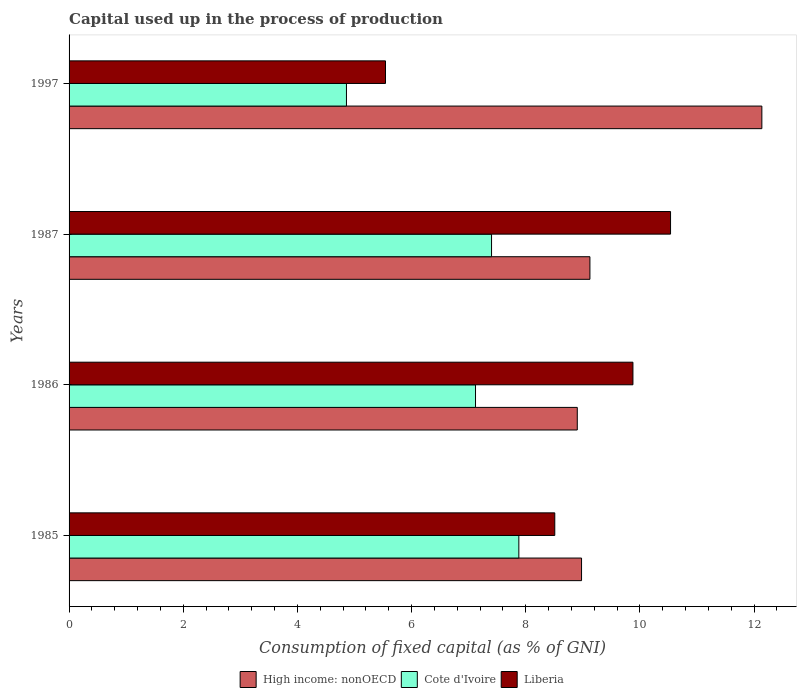How many different coloured bars are there?
Provide a short and direct response. 3. How many groups of bars are there?
Provide a succinct answer. 4. Are the number of bars per tick equal to the number of legend labels?
Keep it short and to the point. Yes. How many bars are there on the 1st tick from the bottom?
Your answer should be compact. 3. In how many cases, is the number of bars for a given year not equal to the number of legend labels?
Your response must be concise. 0. What is the capital used up in the process of production in Cote d'Ivoire in 1986?
Your answer should be very brief. 7.12. Across all years, what is the maximum capital used up in the process of production in High income: nonOECD?
Give a very brief answer. 12.14. Across all years, what is the minimum capital used up in the process of production in High income: nonOECD?
Your response must be concise. 8.9. In which year was the capital used up in the process of production in High income: nonOECD minimum?
Your answer should be compact. 1986. What is the total capital used up in the process of production in Liberia in the graph?
Ensure brevity in your answer.  34.47. What is the difference between the capital used up in the process of production in Liberia in 1986 and that in 1997?
Your response must be concise. 4.34. What is the difference between the capital used up in the process of production in Cote d'Ivoire in 1987 and the capital used up in the process of production in Liberia in 1997?
Offer a very short reply. 1.86. What is the average capital used up in the process of production in High income: nonOECD per year?
Your answer should be very brief. 9.79. In the year 1987, what is the difference between the capital used up in the process of production in Cote d'Ivoire and capital used up in the process of production in High income: nonOECD?
Give a very brief answer. -1.72. In how many years, is the capital used up in the process of production in Liberia greater than 4.4 %?
Give a very brief answer. 4. What is the ratio of the capital used up in the process of production in Liberia in 1987 to that in 1997?
Offer a very short reply. 1.9. Is the capital used up in the process of production in Cote d'Ivoire in 1987 less than that in 1997?
Keep it short and to the point. No. Is the difference between the capital used up in the process of production in Cote d'Ivoire in 1986 and 1997 greater than the difference between the capital used up in the process of production in High income: nonOECD in 1986 and 1997?
Your answer should be compact. Yes. What is the difference between the highest and the second highest capital used up in the process of production in Liberia?
Your answer should be very brief. 0.66. What is the difference between the highest and the lowest capital used up in the process of production in High income: nonOECD?
Offer a terse response. 3.23. In how many years, is the capital used up in the process of production in High income: nonOECD greater than the average capital used up in the process of production in High income: nonOECD taken over all years?
Your response must be concise. 1. Is the sum of the capital used up in the process of production in High income: nonOECD in 1985 and 1997 greater than the maximum capital used up in the process of production in Liberia across all years?
Offer a terse response. Yes. What does the 1st bar from the top in 1987 represents?
Your answer should be very brief. Liberia. What does the 1st bar from the bottom in 1997 represents?
Your answer should be very brief. High income: nonOECD. How many bars are there?
Your answer should be compact. 12. Are all the bars in the graph horizontal?
Give a very brief answer. Yes. What is the difference between two consecutive major ticks on the X-axis?
Provide a succinct answer. 2. Are the values on the major ticks of X-axis written in scientific E-notation?
Give a very brief answer. No. Does the graph contain any zero values?
Your answer should be very brief. No. What is the title of the graph?
Your answer should be very brief. Capital used up in the process of production. Does "Mauritania" appear as one of the legend labels in the graph?
Your answer should be very brief. No. What is the label or title of the X-axis?
Your answer should be compact. Consumption of fixed capital (as % of GNI). What is the Consumption of fixed capital (as % of GNI) in High income: nonOECD in 1985?
Provide a succinct answer. 8.98. What is the Consumption of fixed capital (as % of GNI) in Cote d'Ivoire in 1985?
Keep it short and to the point. 7.88. What is the Consumption of fixed capital (as % of GNI) of Liberia in 1985?
Provide a short and direct response. 8.51. What is the Consumption of fixed capital (as % of GNI) of High income: nonOECD in 1986?
Your response must be concise. 8.9. What is the Consumption of fixed capital (as % of GNI) in Cote d'Ivoire in 1986?
Offer a very short reply. 7.12. What is the Consumption of fixed capital (as % of GNI) in Liberia in 1986?
Your answer should be very brief. 9.88. What is the Consumption of fixed capital (as % of GNI) in High income: nonOECD in 1987?
Keep it short and to the point. 9.13. What is the Consumption of fixed capital (as % of GNI) of Cote d'Ivoire in 1987?
Offer a very short reply. 7.4. What is the Consumption of fixed capital (as % of GNI) of Liberia in 1987?
Provide a succinct answer. 10.54. What is the Consumption of fixed capital (as % of GNI) of High income: nonOECD in 1997?
Ensure brevity in your answer.  12.14. What is the Consumption of fixed capital (as % of GNI) in Cote d'Ivoire in 1997?
Offer a terse response. 4.86. What is the Consumption of fixed capital (as % of GNI) in Liberia in 1997?
Your response must be concise. 5.54. Across all years, what is the maximum Consumption of fixed capital (as % of GNI) in High income: nonOECD?
Keep it short and to the point. 12.14. Across all years, what is the maximum Consumption of fixed capital (as % of GNI) in Cote d'Ivoire?
Give a very brief answer. 7.88. Across all years, what is the maximum Consumption of fixed capital (as % of GNI) in Liberia?
Your answer should be very brief. 10.54. Across all years, what is the minimum Consumption of fixed capital (as % of GNI) of High income: nonOECD?
Your answer should be very brief. 8.9. Across all years, what is the minimum Consumption of fixed capital (as % of GNI) in Cote d'Ivoire?
Provide a short and direct response. 4.86. Across all years, what is the minimum Consumption of fixed capital (as % of GNI) of Liberia?
Offer a terse response. 5.54. What is the total Consumption of fixed capital (as % of GNI) of High income: nonOECD in the graph?
Provide a short and direct response. 39.14. What is the total Consumption of fixed capital (as % of GNI) of Cote d'Ivoire in the graph?
Make the answer very short. 27.26. What is the total Consumption of fixed capital (as % of GNI) in Liberia in the graph?
Give a very brief answer. 34.47. What is the difference between the Consumption of fixed capital (as % of GNI) in High income: nonOECD in 1985 and that in 1986?
Your answer should be very brief. 0.07. What is the difference between the Consumption of fixed capital (as % of GNI) of Cote d'Ivoire in 1985 and that in 1986?
Make the answer very short. 0.76. What is the difference between the Consumption of fixed capital (as % of GNI) of Liberia in 1985 and that in 1986?
Keep it short and to the point. -1.37. What is the difference between the Consumption of fixed capital (as % of GNI) of High income: nonOECD in 1985 and that in 1987?
Make the answer very short. -0.15. What is the difference between the Consumption of fixed capital (as % of GNI) of Cote d'Ivoire in 1985 and that in 1987?
Ensure brevity in your answer.  0.48. What is the difference between the Consumption of fixed capital (as % of GNI) of Liberia in 1985 and that in 1987?
Offer a very short reply. -2.03. What is the difference between the Consumption of fixed capital (as % of GNI) in High income: nonOECD in 1985 and that in 1997?
Ensure brevity in your answer.  -3.16. What is the difference between the Consumption of fixed capital (as % of GNI) of Cote d'Ivoire in 1985 and that in 1997?
Offer a terse response. 3.02. What is the difference between the Consumption of fixed capital (as % of GNI) of Liberia in 1985 and that in 1997?
Your answer should be compact. 2.97. What is the difference between the Consumption of fixed capital (as % of GNI) in High income: nonOECD in 1986 and that in 1987?
Offer a terse response. -0.22. What is the difference between the Consumption of fixed capital (as % of GNI) in Cote d'Ivoire in 1986 and that in 1987?
Provide a short and direct response. -0.28. What is the difference between the Consumption of fixed capital (as % of GNI) in Liberia in 1986 and that in 1987?
Your response must be concise. -0.66. What is the difference between the Consumption of fixed capital (as % of GNI) in High income: nonOECD in 1986 and that in 1997?
Give a very brief answer. -3.23. What is the difference between the Consumption of fixed capital (as % of GNI) in Cote d'Ivoire in 1986 and that in 1997?
Make the answer very short. 2.26. What is the difference between the Consumption of fixed capital (as % of GNI) in Liberia in 1986 and that in 1997?
Your answer should be compact. 4.33. What is the difference between the Consumption of fixed capital (as % of GNI) of High income: nonOECD in 1987 and that in 1997?
Your answer should be very brief. -3.01. What is the difference between the Consumption of fixed capital (as % of GNI) of Cote d'Ivoire in 1987 and that in 1997?
Your response must be concise. 2.54. What is the difference between the Consumption of fixed capital (as % of GNI) in Liberia in 1987 and that in 1997?
Provide a succinct answer. 4.99. What is the difference between the Consumption of fixed capital (as % of GNI) in High income: nonOECD in 1985 and the Consumption of fixed capital (as % of GNI) in Cote d'Ivoire in 1986?
Keep it short and to the point. 1.86. What is the difference between the Consumption of fixed capital (as % of GNI) of High income: nonOECD in 1985 and the Consumption of fixed capital (as % of GNI) of Liberia in 1986?
Your response must be concise. -0.9. What is the difference between the Consumption of fixed capital (as % of GNI) in Cote d'Ivoire in 1985 and the Consumption of fixed capital (as % of GNI) in Liberia in 1986?
Your answer should be very brief. -2. What is the difference between the Consumption of fixed capital (as % of GNI) of High income: nonOECD in 1985 and the Consumption of fixed capital (as % of GNI) of Cote d'Ivoire in 1987?
Provide a short and direct response. 1.58. What is the difference between the Consumption of fixed capital (as % of GNI) of High income: nonOECD in 1985 and the Consumption of fixed capital (as % of GNI) of Liberia in 1987?
Provide a short and direct response. -1.56. What is the difference between the Consumption of fixed capital (as % of GNI) in Cote d'Ivoire in 1985 and the Consumption of fixed capital (as % of GNI) in Liberia in 1987?
Offer a terse response. -2.66. What is the difference between the Consumption of fixed capital (as % of GNI) in High income: nonOECD in 1985 and the Consumption of fixed capital (as % of GNI) in Cote d'Ivoire in 1997?
Keep it short and to the point. 4.12. What is the difference between the Consumption of fixed capital (as % of GNI) of High income: nonOECD in 1985 and the Consumption of fixed capital (as % of GNI) of Liberia in 1997?
Make the answer very short. 3.43. What is the difference between the Consumption of fixed capital (as % of GNI) of Cote d'Ivoire in 1985 and the Consumption of fixed capital (as % of GNI) of Liberia in 1997?
Ensure brevity in your answer.  2.34. What is the difference between the Consumption of fixed capital (as % of GNI) in High income: nonOECD in 1986 and the Consumption of fixed capital (as % of GNI) in Cote d'Ivoire in 1987?
Give a very brief answer. 1.5. What is the difference between the Consumption of fixed capital (as % of GNI) of High income: nonOECD in 1986 and the Consumption of fixed capital (as % of GNI) of Liberia in 1987?
Keep it short and to the point. -1.63. What is the difference between the Consumption of fixed capital (as % of GNI) of Cote d'Ivoire in 1986 and the Consumption of fixed capital (as % of GNI) of Liberia in 1987?
Your answer should be very brief. -3.42. What is the difference between the Consumption of fixed capital (as % of GNI) in High income: nonOECD in 1986 and the Consumption of fixed capital (as % of GNI) in Cote d'Ivoire in 1997?
Provide a short and direct response. 4.04. What is the difference between the Consumption of fixed capital (as % of GNI) of High income: nonOECD in 1986 and the Consumption of fixed capital (as % of GNI) of Liberia in 1997?
Your answer should be very brief. 3.36. What is the difference between the Consumption of fixed capital (as % of GNI) in Cote d'Ivoire in 1986 and the Consumption of fixed capital (as % of GNI) in Liberia in 1997?
Make the answer very short. 1.58. What is the difference between the Consumption of fixed capital (as % of GNI) of High income: nonOECD in 1987 and the Consumption of fixed capital (as % of GNI) of Cote d'Ivoire in 1997?
Your answer should be compact. 4.27. What is the difference between the Consumption of fixed capital (as % of GNI) of High income: nonOECD in 1987 and the Consumption of fixed capital (as % of GNI) of Liberia in 1997?
Offer a terse response. 3.58. What is the difference between the Consumption of fixed capital (as % of GNI) of Cote d'Ivoire in 1987 and the Consumption of fixed capital (as % of GNI) of Liberia in 1997?
Your answer should be compact. 1.86. What is the average Consumption of fixed capital (as % of GNI) of High income: nonOECD per year?
Provide a short and direct response. 9.79. What is the average Consumption of fixed capital (as % of GNI) in Cote d'Ivoire per year?
Your answer should be compact. 6.82. What is the average Consumption of fixed capital (as % of GNI) in Liberia per year?
Make the answer very short. 8.62. In the year 1985, what is the difference between the Consumption of fixed capital (as % of GNI) of High income: nonOECD and Consumption of fixed capital (as % of GNI) of Cote d'Ivoire?
Make the answer very short. 1.1. In the year 1985, what is the difference between the Consumption of fixed capital (as % of GNI) of High income: nonOECD and Consumption of fixed capital (as % of GNI) of Liberia?
Give a very brief answer. 0.47. In the year 1985, what is the difference between the Consumption of fixed capital (as % of GNI) in Cote d'Ivoire and Consumption of fixed capital (as % of GNI) in Liberia?
Keep it short and to the point. -0.63. In the year 1986, what is the difference between the Consumption of fixed capital (as % of GNI) in High income: nonOECD and Consumption of fixed capital (as % of GNI) in Cote d'Ivoire?
Make the answer very short. 1.78. In the year 1986, what is the difference between the Consumption of fixed capital (as % of GNI) in High income: nonOECD and Consumption of fixed capital (as % of GNI) in Liberia?
Your answer should be very brief. -0.98. In the year 1986, what is the difference between the Consumption of fixed capital (as % of GNI) in Cote d'Ivoire and Consumption of fixed capital (as % of GNI) in Liberia?
Provide a succinct answer. -2.76. In the year 1987, what is the difference between the Consumption of fixed capital (as % of GNI) of High income: nonOECD and Consumption of fixed capital (as % of GNI) of Cote d'Ivoire?
Ensure brevity in your answer.  1.72. In the year 1987, what is the difference between the Consumption of fixed capital (as % of GNI) of High income: nonOECD and Consumption of fixed capital (as % of GNI) of Liberia?
Give a very brief answer. -1.41. In the year 1987, what is the difference between the Consumption of fixed capital (as % of GNI) in Cote d'Ivoire and Consumption of fixed capital (as % of GNI) in Liberia?
Keep it short and to the point. -3.14. In the year 1997, what is the difference between the Consumption of fixed capital (as % of GNI) of High income: nonOECD and Consumption of fixed capital (as % of GNI) of Cote d'Ivoire?
Offer a terse response. 7.28. In the year 1997, what is the difference between the Consumption of fixed capital (as % of GNI) in High income: nonOECD and Consumption of fixed capital (as % of GNI) in Liberia?
Provide a short and direct response. 6.59. In the year 1997, what is the difference between the Consumption of fixed capital (as % of GNI) in Cote d'Ivoire and Consumption of fixed capital (as % of GNI) in Liberia?
Provide a succinct answer. -0.68. What is the ratio of the Consumption of fixed capital (as % of GNI) in High income: nonOECD in 1985 to that in 1986?
Your answer should be compact. 1.01. What is the ratio of the Consumption of fixed capital (as % of GNI) of Cote d'Ivoire in 1985 to that in 1986?
Your answer should be compact. 1.11. What is the ratio of the Consumption of fixed capital (as % of GNI) in Liberia in 1985 to that in 1986?
Ensure brevity in your answer.  0.86. What is the ratio of the Consumption of fixed capital (as % of GNI) of High income: nonOECD in 1985 to that in 1987?
Ensure brevity in your answer.  0.98. What is the ratio of the Consumption of fixed capital (as % of GNI) of Cote d'Ivoire in 1985 to that in 1987?
Your response must be concise. 1.06. What is the ratio of the Consumption of fixed capital (as % of GNI) of Liberia in 1985 to that in 1987?
Ensure brevity in your answer.  0.81. What is the ratio of the Consumption of fixed capital (as % of GNI) of High income: nonOECD in 1985 to that in 1997?
Your answer should be very brief. 0.74. What is the ratio of the Consumption of fixed capital (as % of GNI) of Cote d'Ivoire in 1985 to that in 1997?
Your answer should be very brief. 1.62. What is the ratio of the Consumption of fixed capital (as % of GNI) in Liberia in 1985 to that in 1997?
Your answer should be compact. 1.53. What is the ratio of the Consumption of fixed capital (as % of GNI) in High income: nonOECD in 1986 to that in 1987?
Ensure brevity in your answer.  0.98. What is the ratio of the Consumption of fixed capital (as % of GNI) of Cote d'Ivoire in 1986 to that in 1987?
Offer a terse response. 0.96. What is the ratio of the Consumption of fixed capital (as % of GNI) in Liberia in 1986 to that in 1987?
Your answer should be very brief. 0.94. What is the ratio of the Consumption of fixed capital (as % of GNI) of High income: nonOECD in 1986 to that in 1997?
Ensure brevity in your answer.  0.73. What is the ratio of the Consumption of fixed capital (as % of GNI) in Cote d'Ivoire in 1986 to that in 1997?
Your response must be concise. 1.47. What is the ratio of the Consumption of fixed capital (as % of GNI) of Liberia in 1986 to that in 1997?
Provide a short and direct response. 1.78. What is the ratio of the Consumption of fixed capital (as % of GNI) in High income: nonOECD in 1987 to that in 1997?
Offer a terse response. 0.75. What is the ratio of the Consumption of fixed capital (as % of GNI) of Cote d'Ivoire in 1987 to that in 1997?
Provide a short and direct response. 1.52. What is the ratio of the Consumption of fixed capital (as % of GNI) of Liberia in 1987 to that in 1997?
Ensure brevity in your answer.  1.9. What is the difference between the highest and the second highest Consumption of fixed capital (as % of GNI) in High income: nonOECD?
Keep it short and to the point. 3.01. What is the difference between the highest and the second highest Consumption of fixed capital (as % of GNI) of Cote d'Ivoire?
Your response must be concise. 0.48. What is the difference between the highest and the second highest Consumption of fixed capital (as % of GNI) of Liberia?
Give a very brief answer. 0.66. What is the difference between the highest and the lowest Consumption of fixed capital (as % of GNI) in High income: nonOECD?
Ensure brevity in your answer.  3.23. What is the difference between the highest and the lowest Consumption of fixed capital (as % of GNI) in Cote d'Ivoire?
Your response must be concise. 3.02. What is the difference between the highest and the lowest Consumption of fixed capital (as % of GNI) of Liberia?
Offer a very short reply. 4.99. 